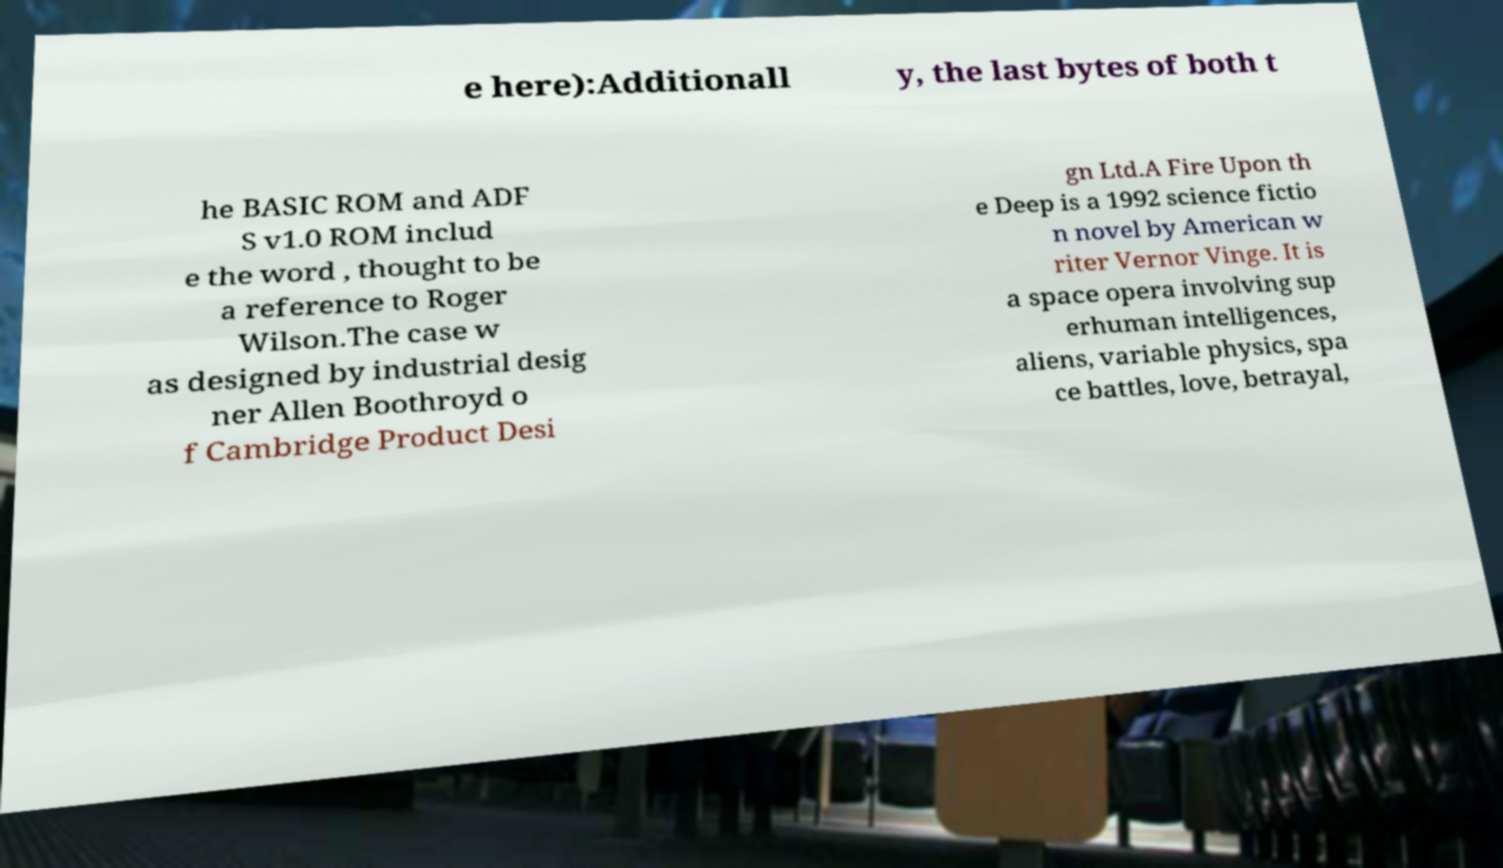There's text embedded in this image that I need extracted. Can you transcribe it verbatim? e here):Additionall y, the last bytes of both t he BASIC ROM and ADF S v1.0 ROM includ e the word , thought to be a reference to Roger Wilson.The case w as designed by industrial desig ner Allen Boothroyd o f Cambridge Product Desi gn Ltd.A Fire Upon th e Deep is a 1992 science fictio n novel by American w riter Vernor Vinge. It is a space opera involving sup erhuman intelligences, aliens, variable physics, spa ce battles, love, betrayal, 